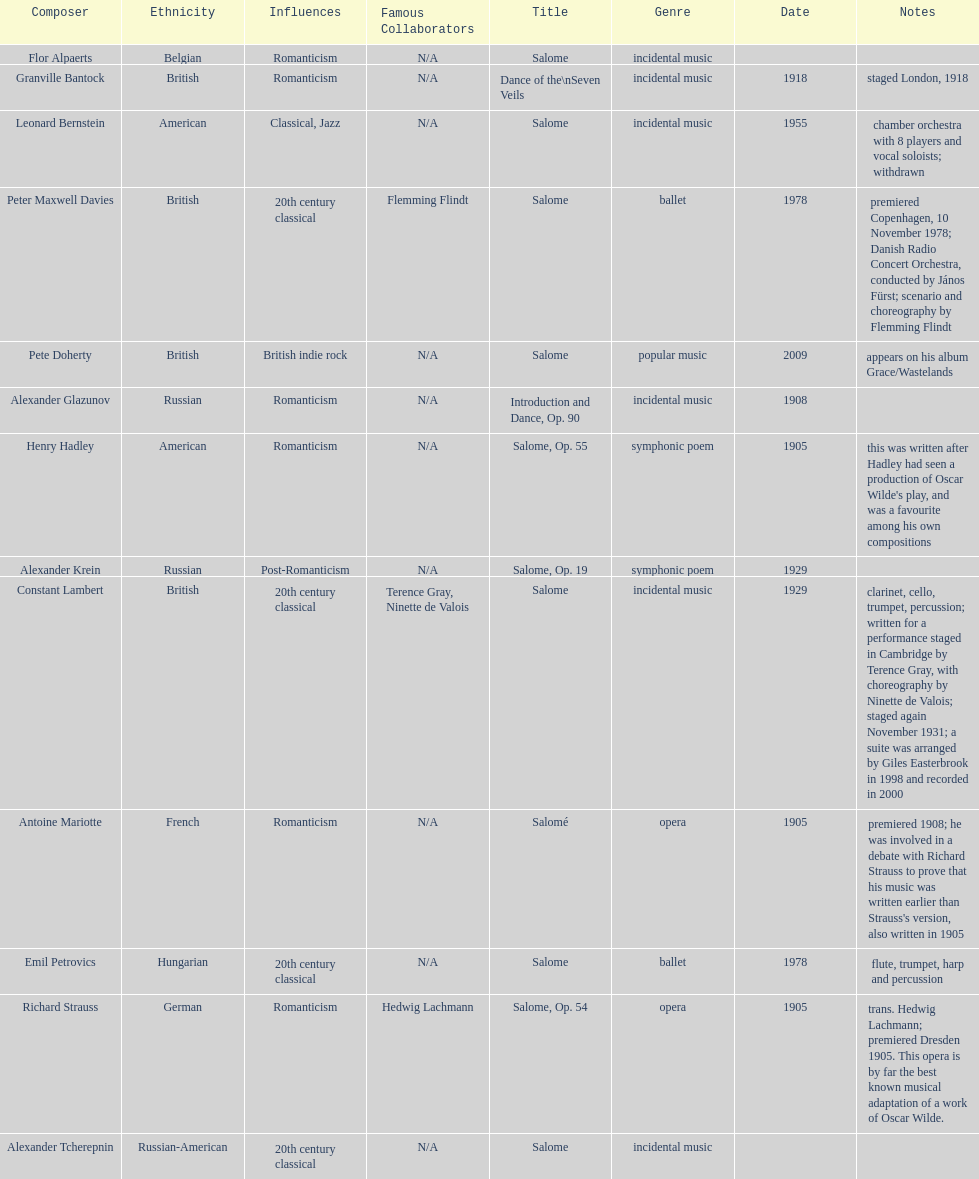What work was written after henry hadley had seen an oscar wilde play? Salome, Op. 55. 